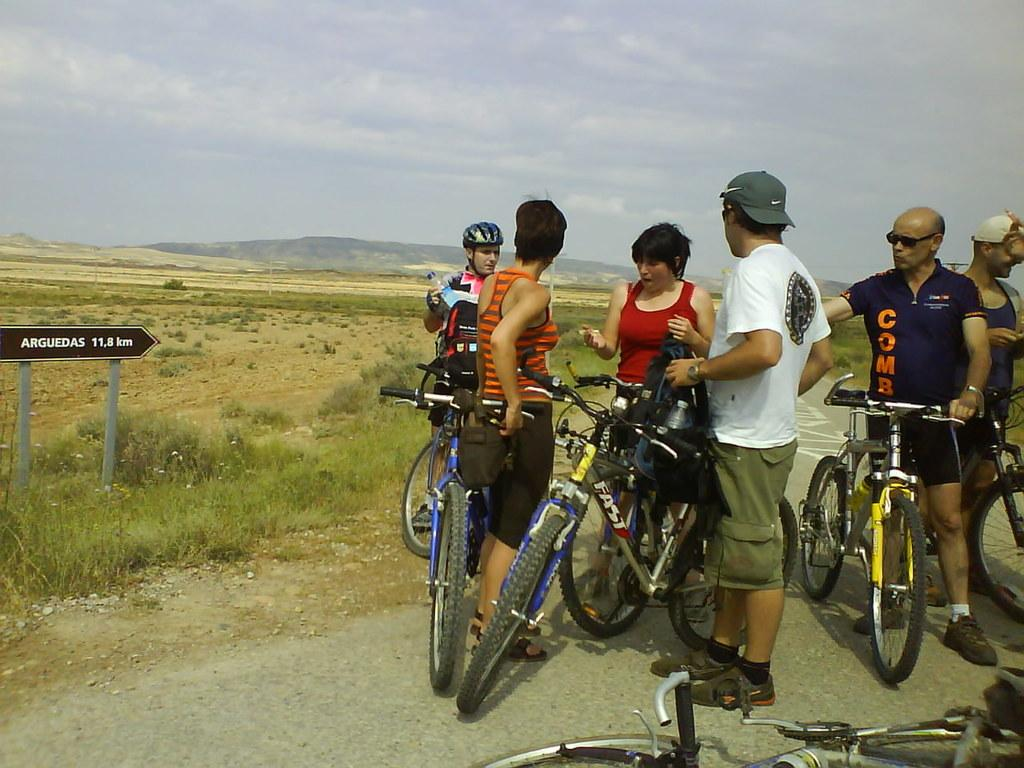How many people are in the image? There is a group of people in the image, but the exact number is not specified. What are the people doing in the image? The people are standing beside bicycles. What type of toys can be seen in the image? There are no toys present in the image; it features a group of people standing beside bicycles. What is the chance of winning a prize in the image? There is no indication of a prize or any game of chance in the image. 